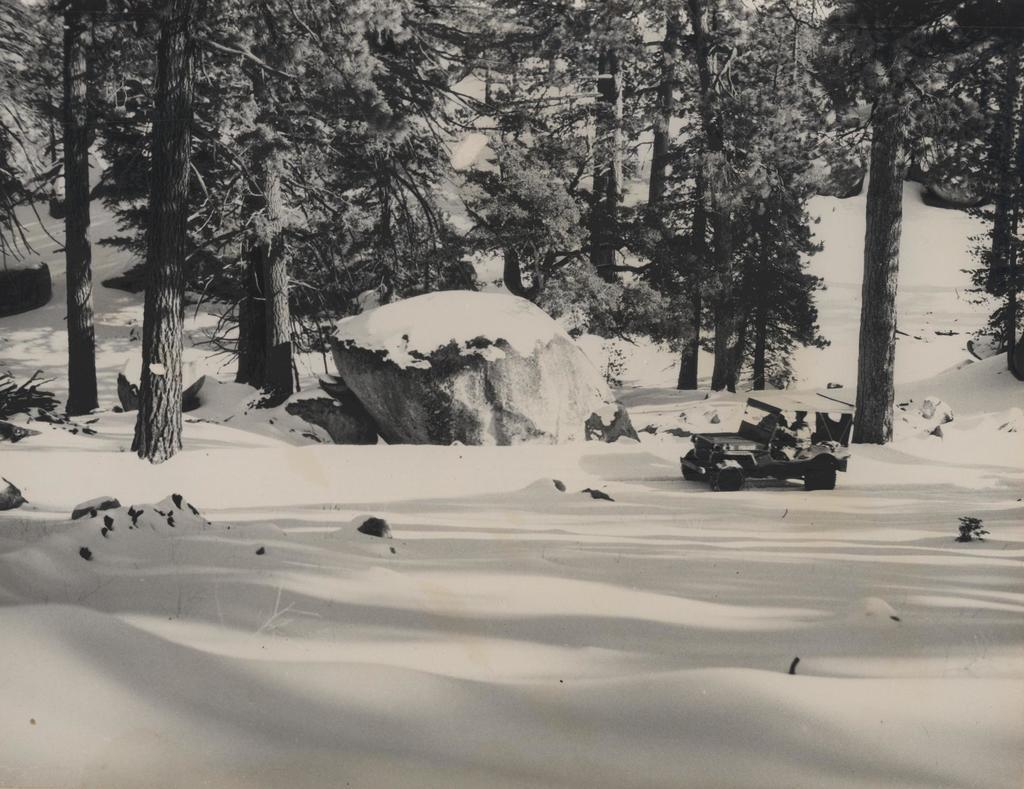Could you give a brief overview of what you see in this image? In this picture we can see a person in a jeep on the snowy ground. In the background, we can see many trees and rocks covered with snow. 